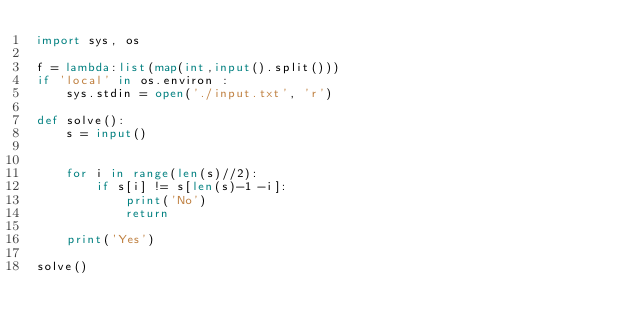Convert code to text. <code><loc_0><loc_0><loc_500><loc_500><_Python_>import sys, os

f = lambda:list(map(int,input().split()))
if 'local' in os.environ :
    sys.stdin = open('./input.txt', 'r')

def solve():
    s = input()


    for i in range(len(s)//2):
        if s[i] != s[len(s)-1 -i]:
            print('No')
            return
    
    print('Yes')

solve()
</code> 